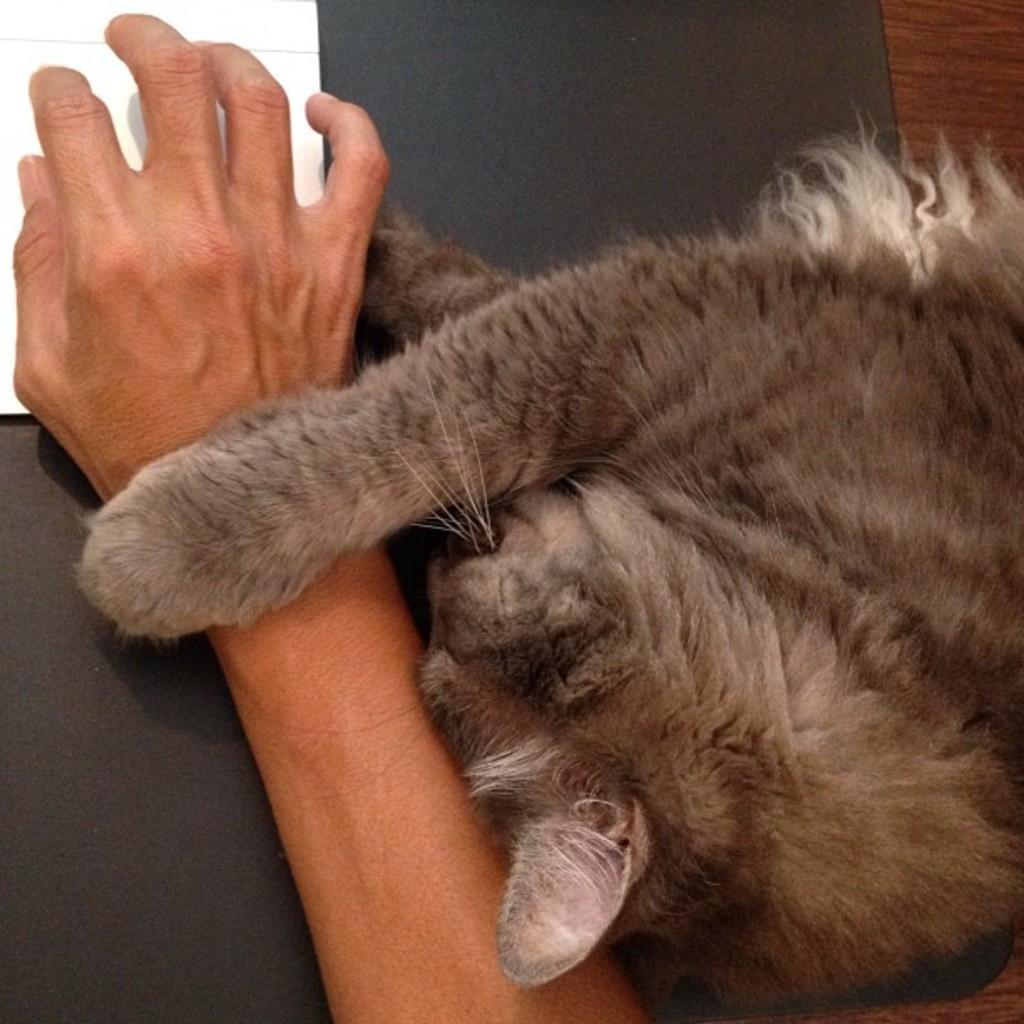Please provide a concise description of this image. In this image, I can see a cat lying on the table. This is a person's hand. This looks like an object, which is white in color. I think this is a mat on the table, which is black in color. 